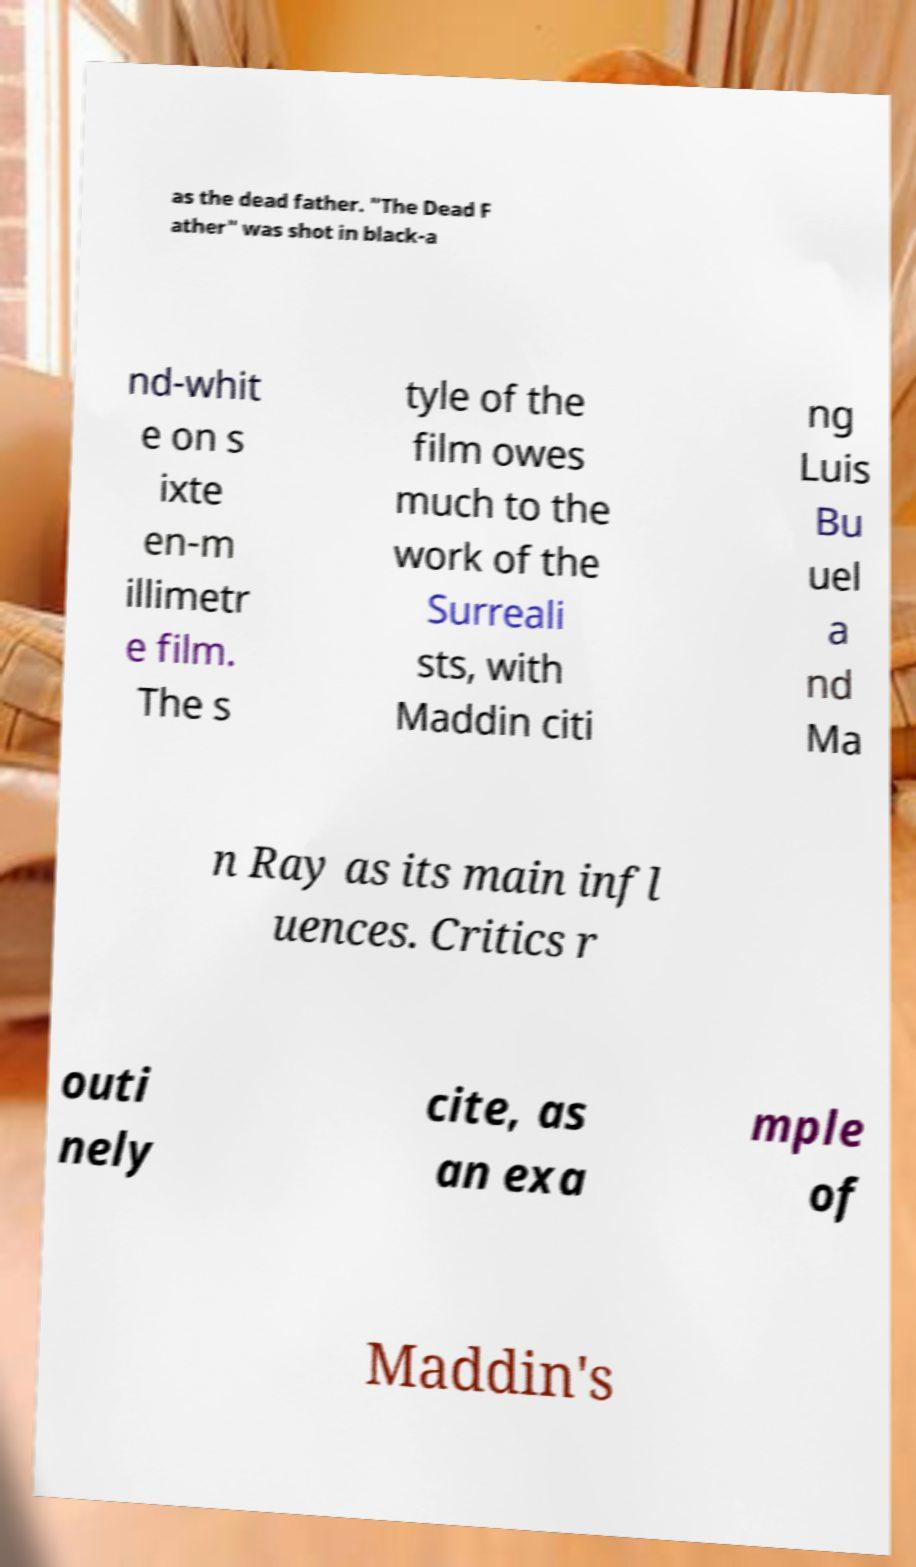I need the written content from this picture converted into text. Can you do that? as the dead father. "The Dead F ather" was shot in black-a nd-whit e on s ixte en-m illimetr e film. The s tyle of the film owes much to the work of the Surreali sts, with Maddin citi ng Luis Bu uel a nd Ma n Ray as its main infl uences. Critics r outi nely cite, as an exa mple of Maddin's 